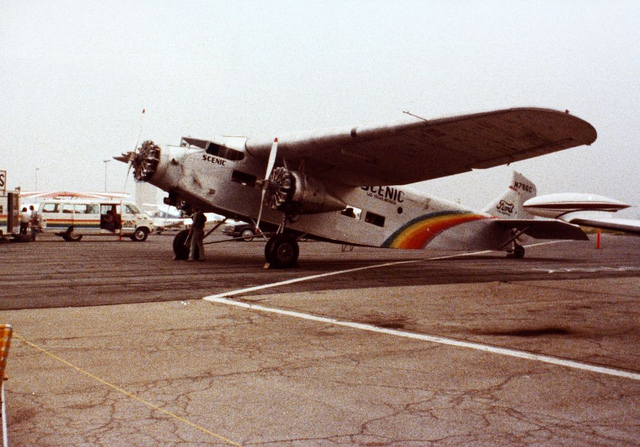Can you tell if this airplane is still in operation or just for display? Based on the markings 'Scenic' on the plane, which suggest use for scenic flights, and the overall good condition as seen in the image, it's likely that this Ford Trimotor is still operational, mainly for touristic or educational purposes rather than commercial flights. How is it maintained in such good condition? Vintage aircraft like this Ford Trimotor are typically maintained through meticulous restorations and regular maintenance by specialists. Preservation efforts often involve sourcing period-specific parts and adhering closely to historical preservation standards to keep them operational for educational or touristic experience. 